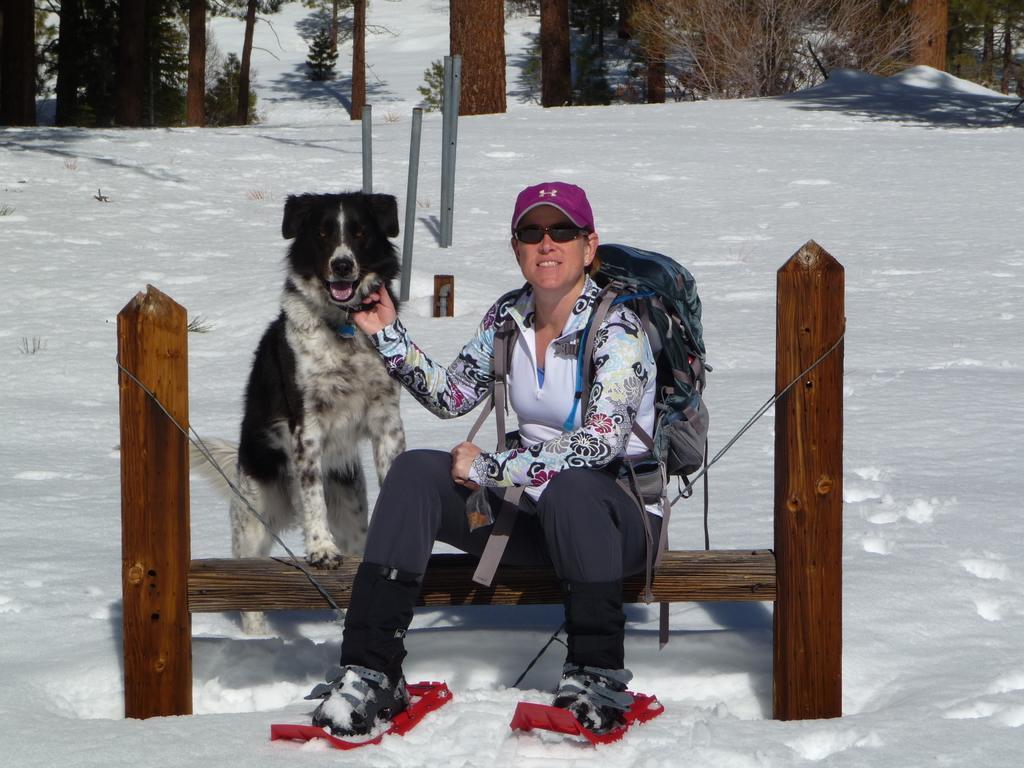Can you describe this image briefly? In the image there is a lady sitting on the wooden log. She kept goggles and there is a cap on her head. And she is wearing bag. Beside her there is a dog is standing. And on the ground there is snow. At the top of the image there are trees. 